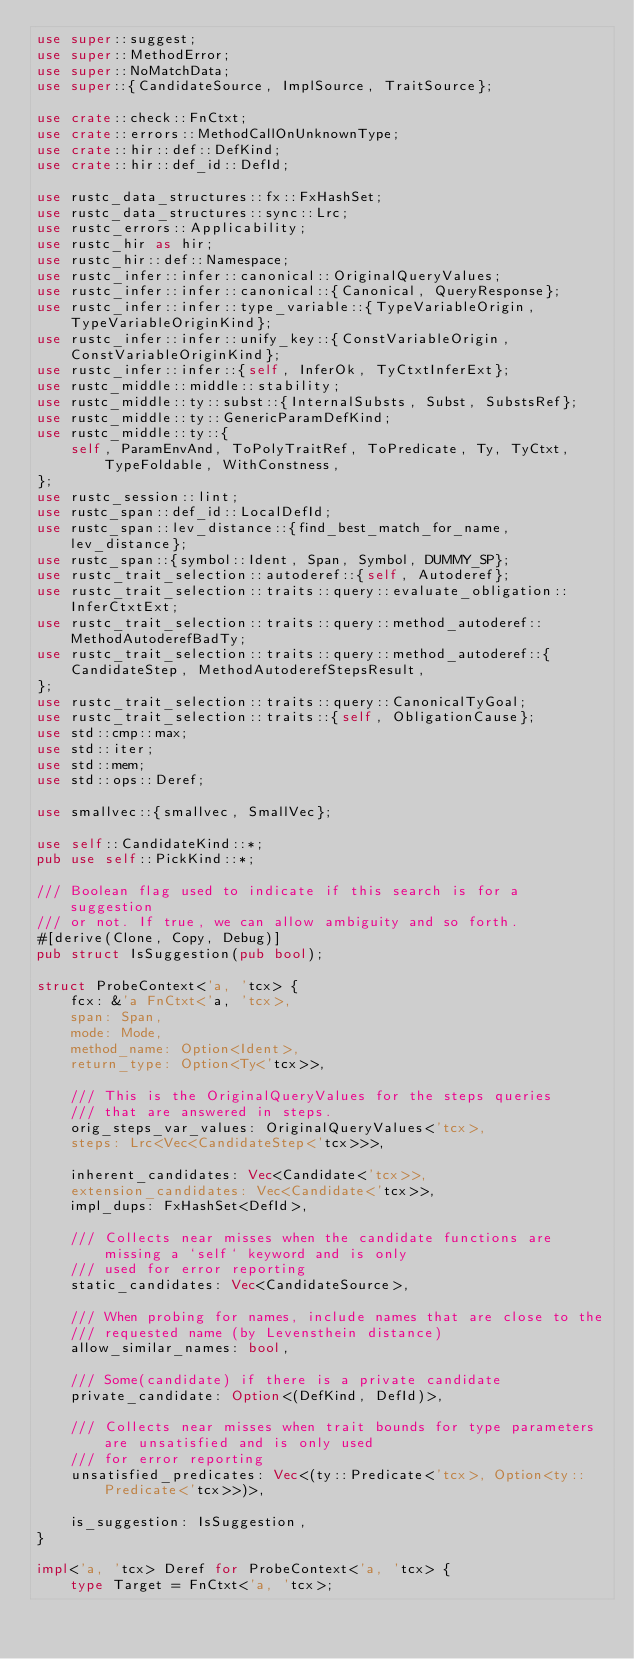<code> <loc_0><loc_0><loc_500><loc_500><_Rust_>use super::suggest;
use super::MethodError;
use super::NoMatchData;
use super::{CandidateSource, ImplSource, TraitSource};

use crate::check::FnCtxt;
use crate::errors::MethodCallOnUnknownType;
use crate::hir::def::DefKind;
use crate::hir::def_id::DefId;

use rustc_data_structures::fx::FxHashSet;
use rustc_data_structures::sync::Lrc;
use rustc_errors::Applicability;
use rustc_hir as hir;
use rustc_hir::def::Namespace;
use rustc_infer::infer::canonical::OriginalQueryValues;
use rustc_infer::infer::canonical::{Canonical, QueryResponse};
use rustc_infer::infer::type_variable::{TypeVariableOrigin, TypeVariableOriginKind};
use rustc_infer::infer::unify_key::{ConstVariableOrigin, ConstVariableOriginKind};
use rustc_infer::infer::{self, InferOk, TyCtxtInferExt};
use rustc_middle::middle::stability;
use rustc_middle::ty::subst::{InternalSubsts, Subst, SubstsRef};
use rustc_middle::ty::GenericParamDefKind;
use rustc_middle::ty::{
    self, ParamEnvAnd, ToPolyTraitRef, ToPredicate, Ty, TyCtxt, TypeFoldable, WithConstness,
};
use rustc_session::lint;
use rustc_span::def_id::LocalDefId;
use rustc_span::lev_distance::{find_best_match_for_name, lev_distance};
use rustc_span::{symbol::Ident, Span, Symbol, DUMMY_SP};
use rustc_trait_selection::autoderef::{self, Autoderef};
use rustc_trait_selection::traits::query::evaluate_obligation::InferCtxtExt;
use rustc_trait_selection::traits::query::method_autoderef::MethodAutoderefBadTy;
use rustc_trait_selection::traits::query::method_autoderef::{
    CandidateStep, MethodAutoderefStepsResult,
};
use rustc_trait_selection::traits::query::CanonicalTyGoal;
use rustc_trait_selection::traits::{self, ObligationCause};
use std::cmp::max;
use std::iter;
use std::mem;
use std::ops::Deref;

use smallvec::{smallvec, SmallVec};

use self::CandidateKind::*;
pub use self::PickKind::*;

/// Boolean flag used to indicate if this search is for a suggestion
/// or not. If true, we can allow ambiguity and so forth.
#[derive(Clone, Copy, Debug)]
pub struct IsSuggestion(pub bool);

struct ProbeContext<'a, 'tcx> {
    fcx: &'a FnCtxt<'a, 'tcx>,
    span: Span,
    mode: Mode,
    method_name: Option<Ident>,
    return_type: Option<Ty<'tcx>>,

    /// This is the OriginalQueryValues for the steps queries
    /// that are answered in steps.
    orig_steps_var_values: OriginalQueryValues<'tcx>,
    steps: Lrc<Vec<CandidateStep<'tcx>>>,

    inherent_candidates: Vec<Candidate<'tcx>>,
    extension_candidates: Vec<Candidate<'tcx>>,
    impl_dups: FxHashSet<DefId>,

    /// Collects near misses when the candidate functions are missing a `self` keyword and is only
    /// used for error reporting
    static_candidates: Vec<CandidateSource>,

    /// When probing for names, include names that are close to the
    /// requested name (by Levensthein distance)
    allow_similar_names: bool,

    /// Some(candidate) if there is a private candidate
    private_candidate: Option<(DefKind, DefId)>,

    /// Collects near misses when trait bounds for type parameters are unsatisfied and is only used
    /// for error reporting
    unsatisfied_predicates: Vec<(ty::Predicate<'tcx>, Option<ty::Predicate<'tcx>>)>,

    is_suggestion: IsSuggestion,
}

impl<'a, 'tcx> Deref for ProbeContext<'a, 'tcx> {
    type Target = FnCtxt<'a, 'tcx>;</code> 